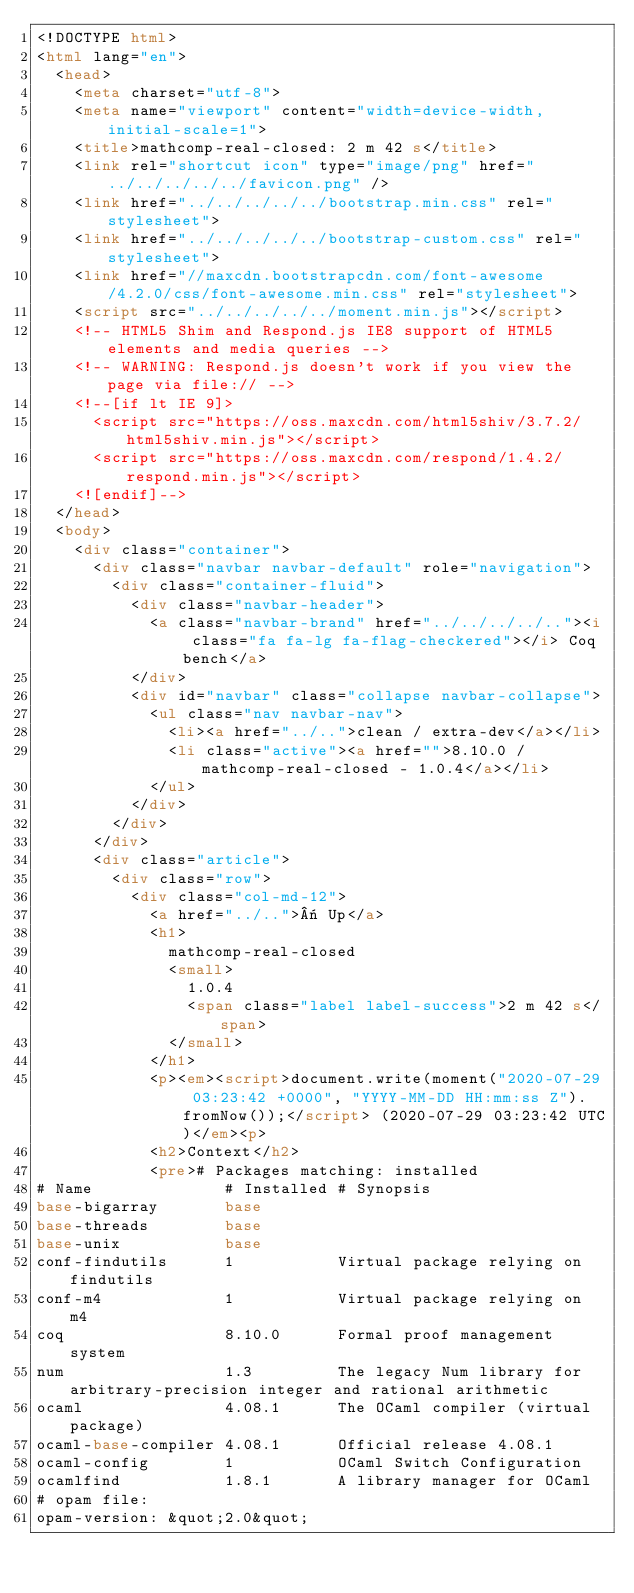Convert code to text. <code><loc_0><loc_0><loc_500><loc_500><_HTML_><!DOCTYPE html>
<html lang="en">
  <head>
    <meta charset="utf-8">
    <meta name="viewport" content="width=device-width, initial-scale=1">
    <title>mathcomp-real-closed: 2 m 42 s</title>
    <link rel="shortcut icon" type="image/png" href="../../../../../favicon.png" />
    <link href="../../../../../bootstrap.min.css" rel="stylesheet">
    <link href="../../../../../bootstrap-custom.css" rel="stylesheet">
    <link href="//maxcdn.bootstrapcdn.com/font-awesome/4.2.0/css/font-awesome.min.css" rel="stylesheet">
    <script src="../../../../../moment.min.js"></script>
    <!-- HTML5 Shim and Respond.js IE8 support of HTML5 elements and media queries -->
    <!-- WARNING: Respond.js doesn't work if you view the page via file:// -->
    <!--[if lt IE 9]>
      <script src="https://oss.maxcdn.com/html5shiv/3.7.2/html5shiv.min.js"></script>
      <script src="https://oss.maxcdn.com/respond/1.4.2/respond.min.js"></script>
    <![endif]-->
  </head>
  <body>
    <div class="container">
      <div class="navbar navbar-default" role="navigation">
        <div class="container-fluid">
          <div class="navbar-header">
            <a class="navbar-brand" href="../../../../.."><i class="fa fa-lg fa-flag-checkered"></i> Coq bench</a>
          </div>
          <div id="navbar" class="collapse navbar-collapse">
            <ul class="nav navbar-nav">
              <li><a href="../..">clean / extra-dev</a></li>
              <li class="active"><a href="">8.10.0 / mathcomp-real-closed - 1.0.4</a></li>
            </ul>
          </div>
        </div>
      </div>
      <div class="article">
        <div class="row">
          <div class="col-md-12">
            <a href="../..">« Up</a>
            <h1>
              mathcomp-real-closed
              <small>
                1.0.4
                <span class="label label-success">2 m 42 s</span>
              </small>
            </h1>
            <p><em><script>document.write(moment("2020-07-29 03:23:42 +0000", "YYYY-MM-DD HH:mm:ss Z").fromNow());</script> (2020-07-29 03:23:42 UTC)</em><p>
            <h2>Context</h2>
            <pre># Packages matching: installed
# Name              # Installed # Synopsis
base-bigarray       base
base-threads        base
base-unix           base
conf-findutils      1           Virtual package relying on findutils
conf-m4             1           Virtual package relying on m4
coq                 8.10.0      Formal proof management system
num                 1.3         The legacy Num library for arbitrary-precision integer and rational arithmetic
ocaml               4.08.1      The OCaml compiler (virtual package)
ocaml-base-compiler 4.08.1      Official release 4.08.1
ocaml-config        1           OCaml Switch Configuration
ocamlfind           1.8.1       A library manager for OCaml
# opam file:
opam-version: &quot;2.0&quot;</code> 